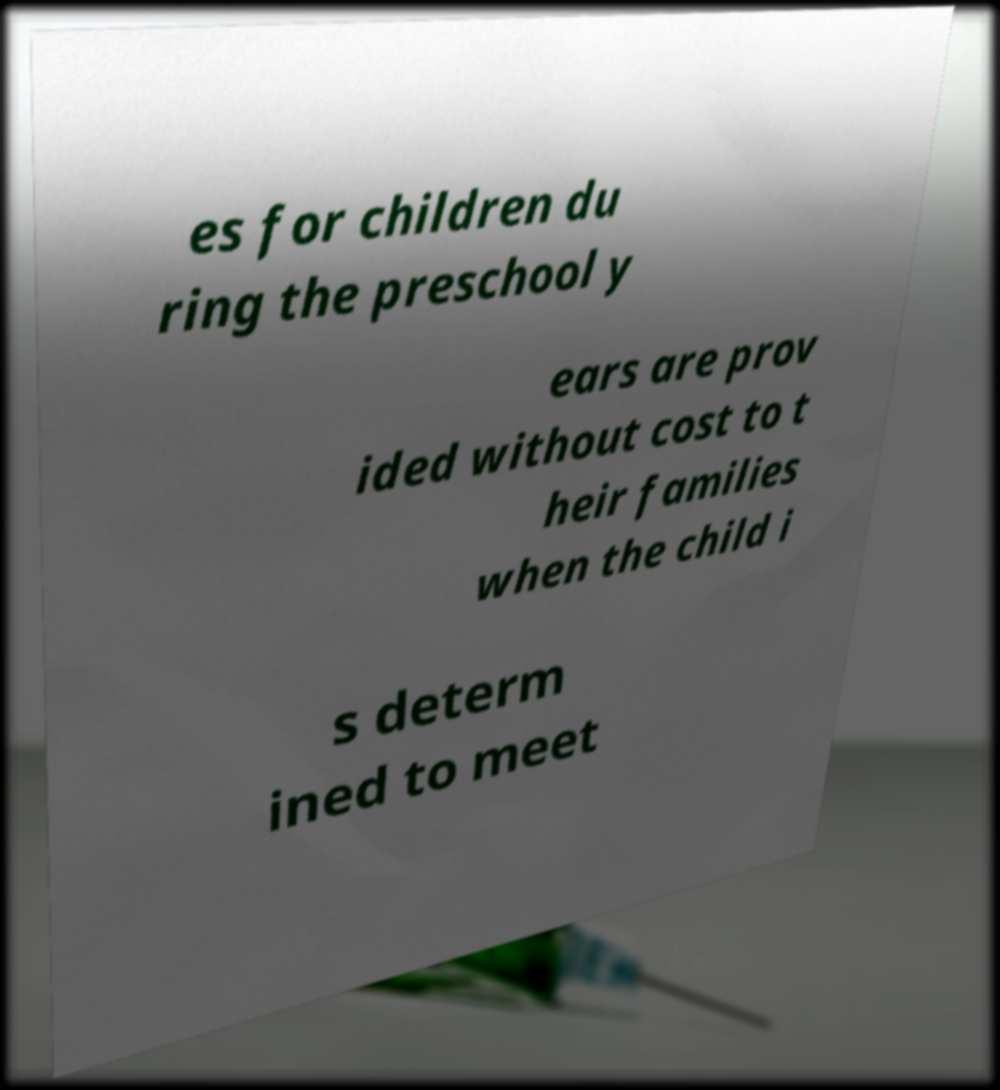What messages or text are displayed in this image? I need them in a readable, typed format. es for children du ring the preschool y ears are prov ided without cost to t heir families when the child i s determ ined to meet 